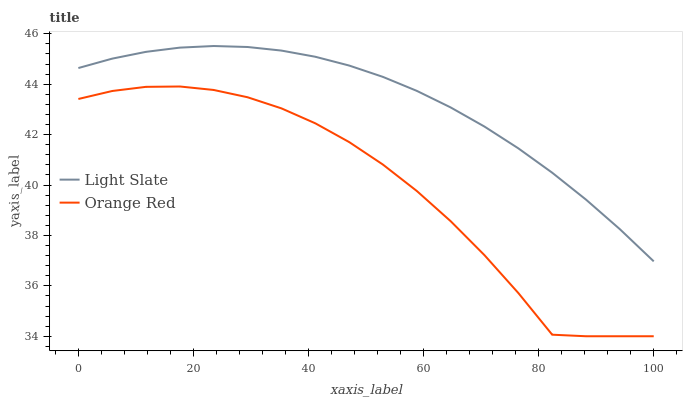Does Orange Red have the maximum area under the curve?
Answer yes or no. No. Is Orange Red the smoothest?
Answer yes or no. No. Does Orange Red have the highest value?
Answer yes or no. No. Is Orange Red less than Light Slate?
Answer yes or no. Yes. Is Light Slate greater than Orange Red?
Answer yes or no. Yes. Does Orange Red intersect Light Slate?
Answer yes or no. No. 